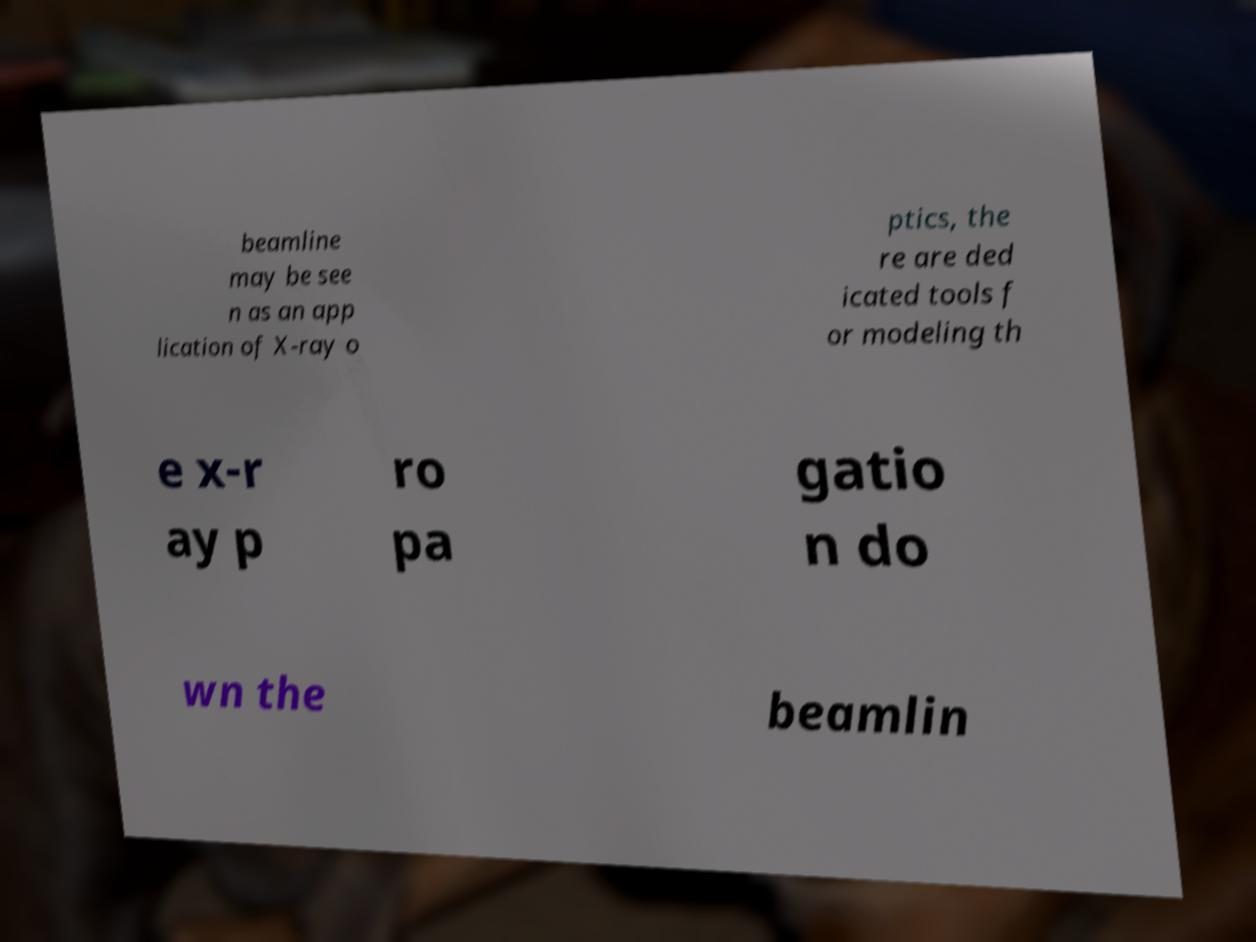What messages or text are displayed in this image? I need them in a readable, typed format. beamline may be see n as an app lication of X-ray o ptics, the re are ded icated tools f or modeling th e x-r ay p ro pa gatio n do wn the beamlin 